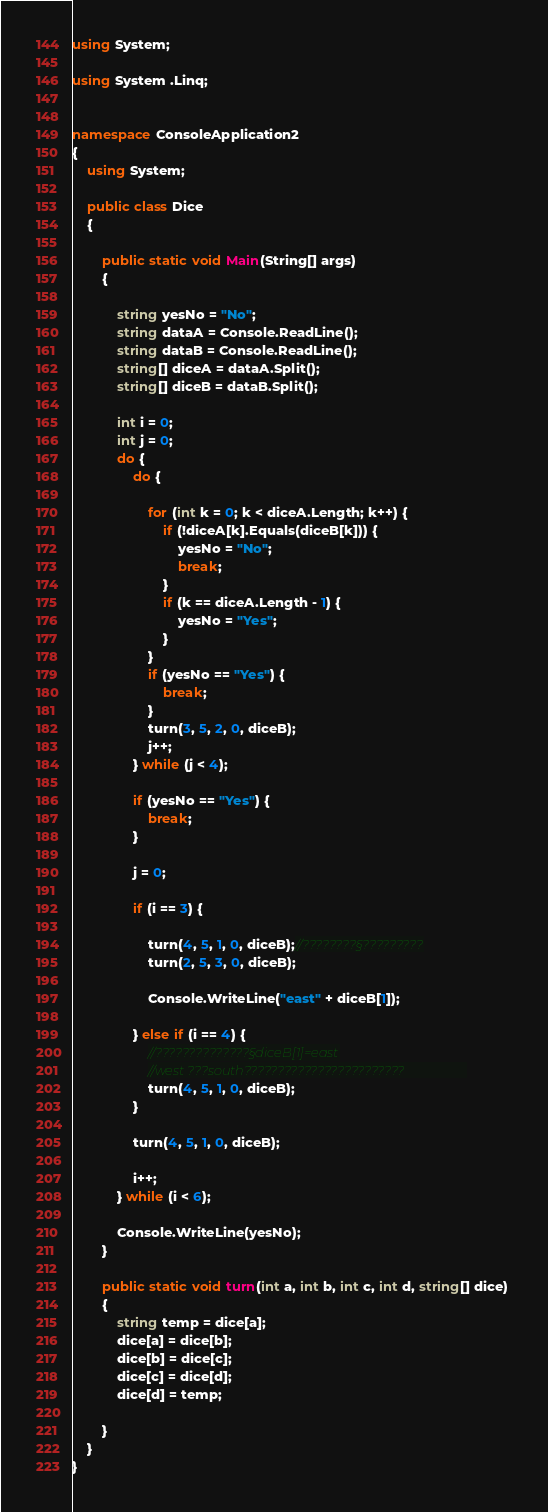<code> <loc_0><loc_0><loc_500><loc_500><_C#_>using System;

using System .Linq;


namespace ConsoleApplication2
{
	using System;

	public class Dice
	{

		public static void Main(String[] args)
		{

			string yesNo = "No";
			string dataA = Console.ReadLine();
			string dataB = Console.ReadLine();
      		string[] diceA = dataA.Split();
     		string[] diceB = dataB.Split();
     		
           	int i = 0;
			int j = 0;
			do {
				do {
                  
					for (int k = 0; k < diceA.Length; k++) {
						if (!diceA[k].Equals(diceB[k])) {
							yesNo = "No";
							break;
						}
						if (k == diceA.Length - 1) {
							yesNo = "Yes";
						}
					}
					if (yesNo == "Yes") {
						break;
					}
					turn(3, 5, 2, 0, diceB);                   
					j++;
				} while (j < 4);

				if (yesNo == "Yes") {
					break;
				}
				
				j = 0;
				
				if (i == 3) {
                   
					turn(4, 5, 1, 0, diceB);//????????§?????????
					turn(2, 5, 3, 0, diceB);

					Console.WriteLine("east" + diceB[1]);
					
				} else if (i == 4) {
					//??????????????§diceB[1]=east
					//west ???south????????????????????????                   
					turn(4, 5, 1, 0, diceB);                       
				}

				turn(4, 5, 1, 0, diceB);
				
				i++;
			} while (i < 6);
			
			Console.WriteLine(yesNo);
		}

		public static void turn(int a, int b, int c, int d, string[] dice)
		{
			string temp = dice[a];
			dice[a] = dice[b];
			dice[b] = dice[c];
			dice[c] = dice[d];
			dice[d] = temp;
            
		}
	}
}</code> 